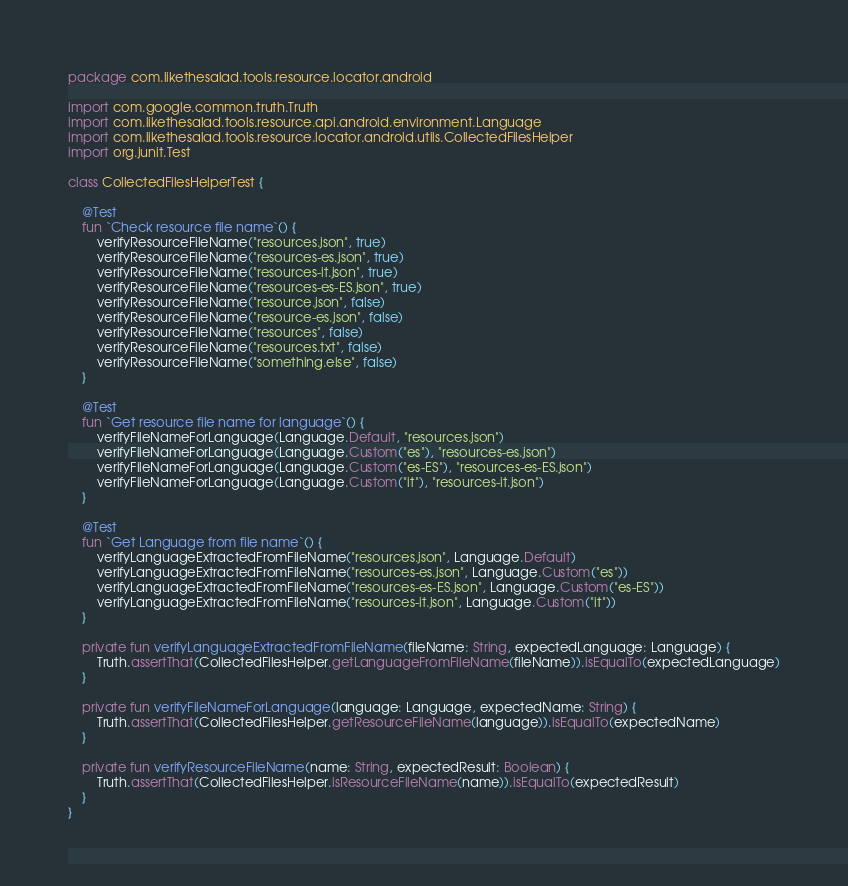Convert code to text. <code><loc_0><loc_0><loc_500><loc_500><_Kotlin_>package com.likethesalad.tools.resource.locator.android

import com.google.common.truth.Truth
import com.likethesalad.tools.resource.api.android.environment.Language
import com.likethesalad.tools.resource.locator.android.utils.CollectedFilesHelper
import org.junit.Test

class CollectedFilesHelperTest {

    @Test
    fun `Check resource file name`() {
        verifyResourceFileName("resources.json", true)
        verifyResourceFileName("resources-es.json", true)
        verifyResourceFileName("resources-it.json", true)
        verifyResourceFileName("resources-es-ES.json", true)
        verifyResourceFileName("resource.json", false)
        verifyResourceFileName("resource-es.json", false)
        verifyResourceFileName("resources", false)
        verifyResourceFileName("resources.txt", false)
        verifyResourceFileName("something.else", false)
    }

    @Test
    fun `Get resource file name for language`() {
        verifyFileNameForLanguage(Language.Default, "resources.json")
        verifyFileNameForLanguage(Language.Custom("es"), "resources-es.json")
        verifyFileNameForLanguage(Language.Custom("es-ES"), "resources-es-ES.json")
        verifyFileNameForLanguage(Language.Custom("it"), "resources-it.json")
    }

    @Test
    fun `Get Language from file name`() {
        verifyLanguageExtractedFromFileName("resources.json", Language.Default)
        verifyLanguageExtractedFromFileName("resources-es.json", Language.Custom("es"))
        verifyLanguageExtractedFromFileName("resources-es-ES.json", Language.Custom("es-ES"))
        verifyLanguageExtractedFromFileName("resources-it.json", Language.Custom("it"))
    }

    private fun verifyLanguageExtractedFromFileName(fileName: String, expectedLanguage: Language) {
        Truth.assertThat(CollectedFilesHelper.getLanguageFromFileName(fileName)).isEqualTo(expectedLanguage)
    }

    private fun verifyFileNameForLanguage(language: Language, expectedName: String) {
        Truth.assertThat(CollectedFilesHelper.getResourceFileName(language)).isEqualTo(expectedName)
    }

    private fun verifyResourceFileName(name: String, expectedResult: Boolean) {
        Truth.assertThat(CollectedFilesHelper.isResourceFileName(name)).isEqualTo(expectedResult)
    }
}</code> 